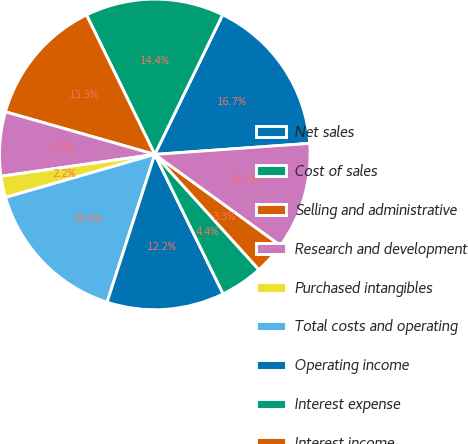<chart> <loc_0><loc_0><loc_500><loc_500><pie_chart><fcel>Net sales<fcel>Cost of sales<fcel>Selling and administrative<fcel>Research and development<fcel>Purchased intangibles<fcel>Total costs and operating<fcel>Operating income<fcel>Interest expense<fcel>Interest income<fcel>Income from operations before<nl><fcel>16.67%<fcel>14.44%<fcel>13.33%<fcel>6.67%<fcel>2.22%<fcel>15.56%<fcel>12.22%<fcel>4.44%<fcel>3.33%<fcel>11.11%<nl></chart> 